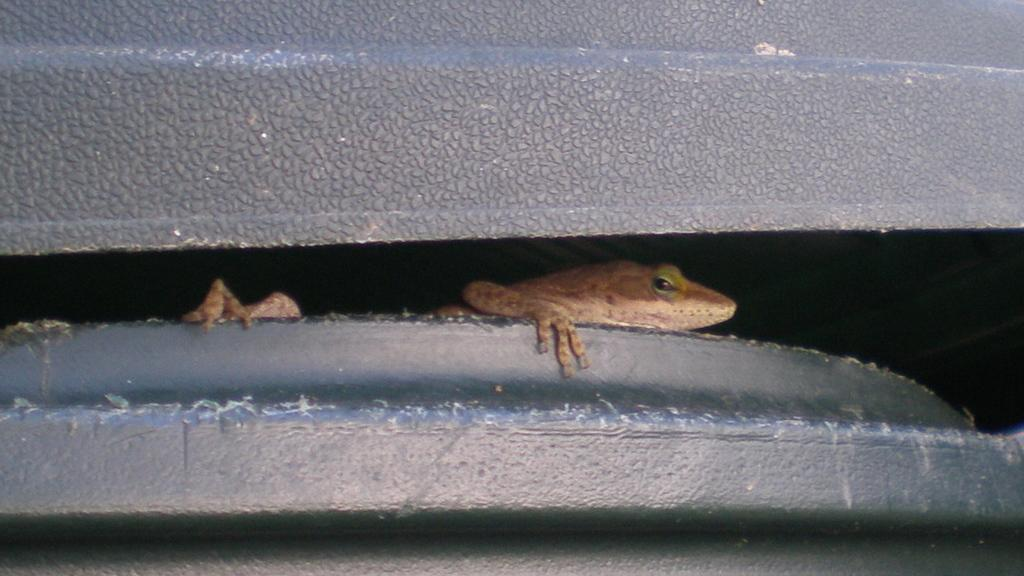What type of animal is in the image? There is a reptile in the image. What is the reptile resting on? The reptile is on a black object. Can you describe the objects at the top and bottom of the image? There is an object at the top and an object at the bottom of the image, but their specific details are not mentioned in the provided facts. What type of expert is giving a presentation during recess in the image? There is no expert or presentation during recess in the image, as it features a reptile resting on a black object. 